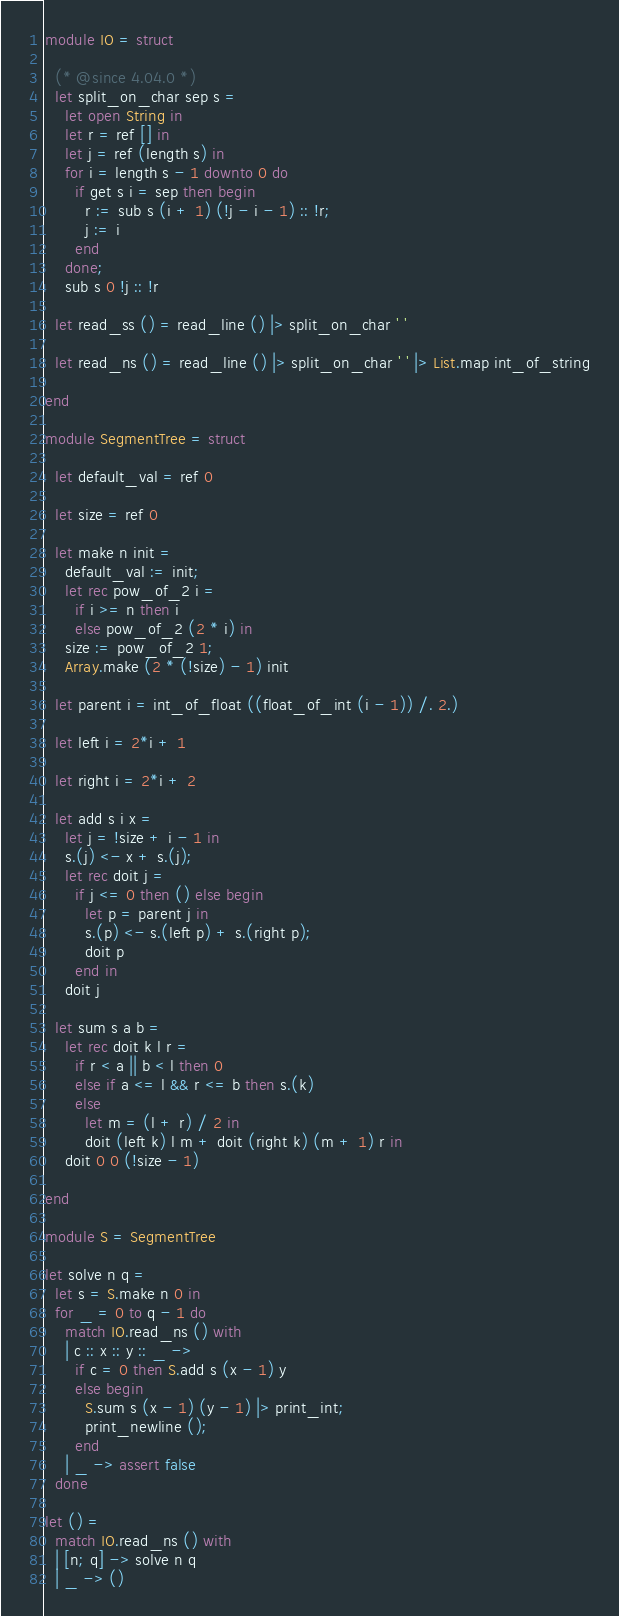Convert code to text. <code><loc_0><loc_0><loc_500><loc_500><_OCaml_>module IO = struct

  (* @since 4.04.0 *)
  let split_on_char sep s =
    let open String in
    let r = ref [] in
    let j = ref (length s) in
    for i = length s - 1 downto 0 do
      if get s i = sep then begin
        r := sub s (i + 1) (!j - i - 1) :: !r;
        j := i
      end
    done;
    sub s 0 !j :: !r

  let read_ss () = read_line () |> split_on_char ' '

  let read_ns () = read_line () |> split_on_char ' ' |> List.map int_of_string

end

module SegmentTree = struct

  let default_val = ref 0

  let size = ref 0

  let make n init =
    default_val := init;
    let rec pow_of_2 i =
      if i >= n then i
      else pow_of_2 (2 * i) in
    size := pow_of_2 1;
    Array.make (2 * (!size) - 1) init

  let parent i = int_of_float ((float_of_int (i - 1)) /. 2.)

  let left i = 2*i + 1

  let right i = 2*i + 2

  let add s i x =
    let j = !size + i - 1 in
    s.(j) <- x + s.(j);
    let rec doit j =
      if j <= 0 then () else begin
        let p = parent j in
        s.(p) <- s.(left p) + s.(right p);
        doit p
      end in
    doit j

  let sum s a b =
    let rec doit k l r =
      if r < a || b < l then 0
      else if a <= l && r <= b then s.(k)
      else
        let m = (l + r) / 2 in
        doit (left k) l m + doit (right k) (m + 1) r in
    doit 0 0 (!size - 1)

end

module S = SegmentTree

let solve n q =
  let s = S.make n 0 in
  for _ = 0 to q - 1 do
    match IO.read_ns () with
    | c :: x :: y :: _ ->
      if c = 0 then S.add s (x - 1) y
      else begin
        S.sum s (x - 1) (y - 1) |> print_int;
        print_newline ();
      end
    | _ -> assert false
  done

let () =
  match IO.read_ns () with
  | [n; q] -> solve n q
  | _ -> ()</code> 